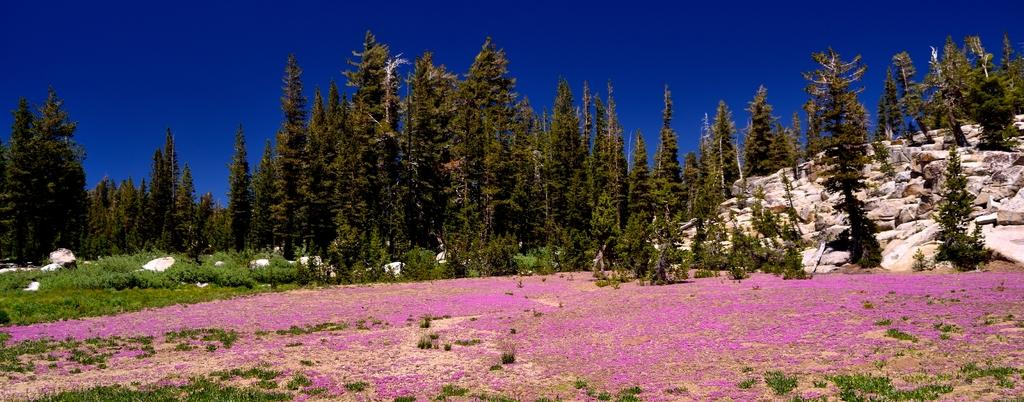What type of vegetation is present in the image? There is a group of trees in the image. What geographical feature can be seen in the image? There is a mountain in the image. What is visible in the background of the image? The sky is visible in the background of the image. Can you tell me how many snails are crawling on the mountain in the image? There are no snails present in the image; it features a group of trees, a mountain, and the sky. What disease is affecting the trees in the image? There is no indication of any disease affecting the trees in the image. 